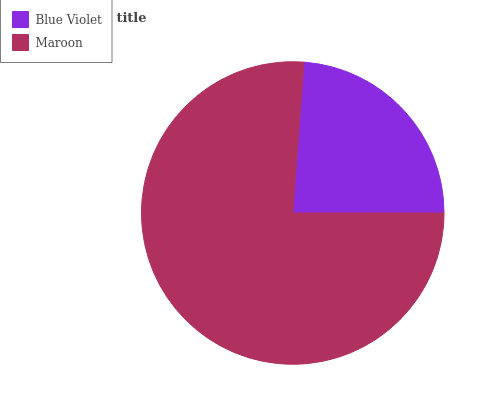Is Blue Violet the minimum?
Answer yes or no. Yes. Is Maroon the maximum?
Answer yes or no. Yes. Is Maroon the minimum?
Answer yes or no. No. Is Maroon greater than Blue Violet?
Answer yes or no. Yes. Is Blue Violet less than Maroon?
Answer yes or no. Yes. Is Blue Violet greater than Maroon?
Answer yes or no. No. Is Maroon less than Blue Violet?
Answer yes or no. No. Is Maroon the high median?
Answer yes or no. Yes. Is Blue Violet the low median?
Answer yes or no. Yes. Is Blue Violet the high median?
Answer yes or no. No. Is Maroon the low median?
Answer yes or no. No. 